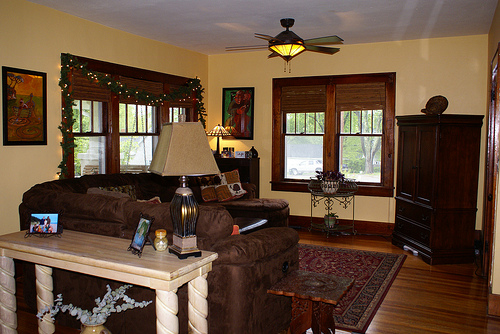Imagine how this room might look in a different era. In a different era, say the early 20th century, this room could transform significantly. The windows might be draped with lace curtains, and the couch would be replaced by a settee with ornate wooden carvings and embroidered upholstery. The wooden floors would likely be covered with thick, plush carpets. Gas lamps would be mounted on the walls, exuding a soft, warm light. The table might be decorated with intricate doilies and topped with a porcelain tea set. A gramophone would sit in the corner, providing music for the household, and a large fireplace would dominate one wall, surrounded by an elaborate mantelpiece displaying various curios and family heirlooms. What modern touches could be added to bring this room into the 21st century? To bring this room into the 21st century, one might add sleek, modern furniture with clean lines and neutral tones. Smart home devices could be integrated, such as voice-activated lighting, a smart thermostat, and a high-quality sound system embedded into the ceiling. The table could sport a minimalist centerpiece, like a geometric vase with a single statement flower or an abstract sculpture. A modern, flat-screen TV might hang above a minimalist, floating entertainment unit. The walls could feature contemporary art pieces or even digital frames that rotate through various artworks. Additionally, wireless charging spots and strategically placed USB outlets would align the room with modern tech needs. 